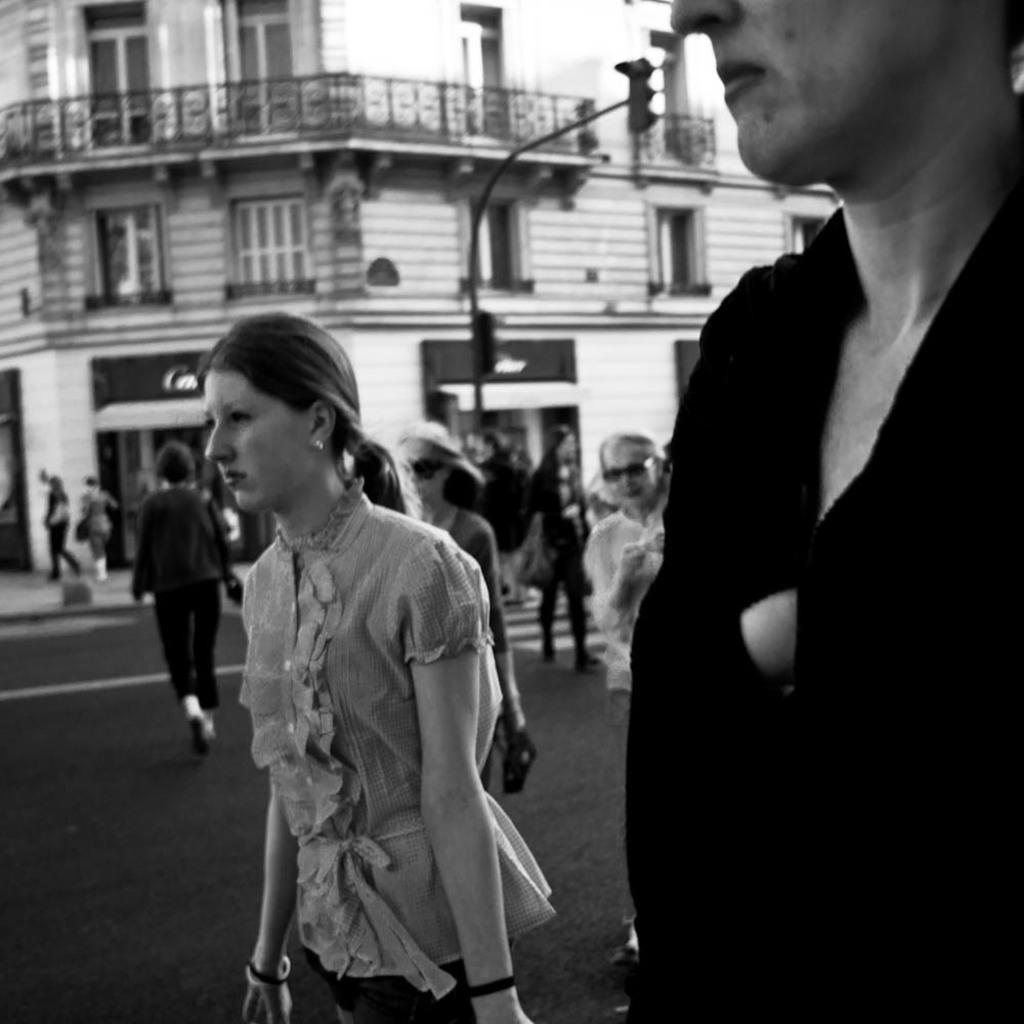In one or two sentences, can you explain what this image depicts? This is the black and white image where we can see these people are walking on the road. The background of the image is slightly blurred, where we can see traffic signal poles and the building. 